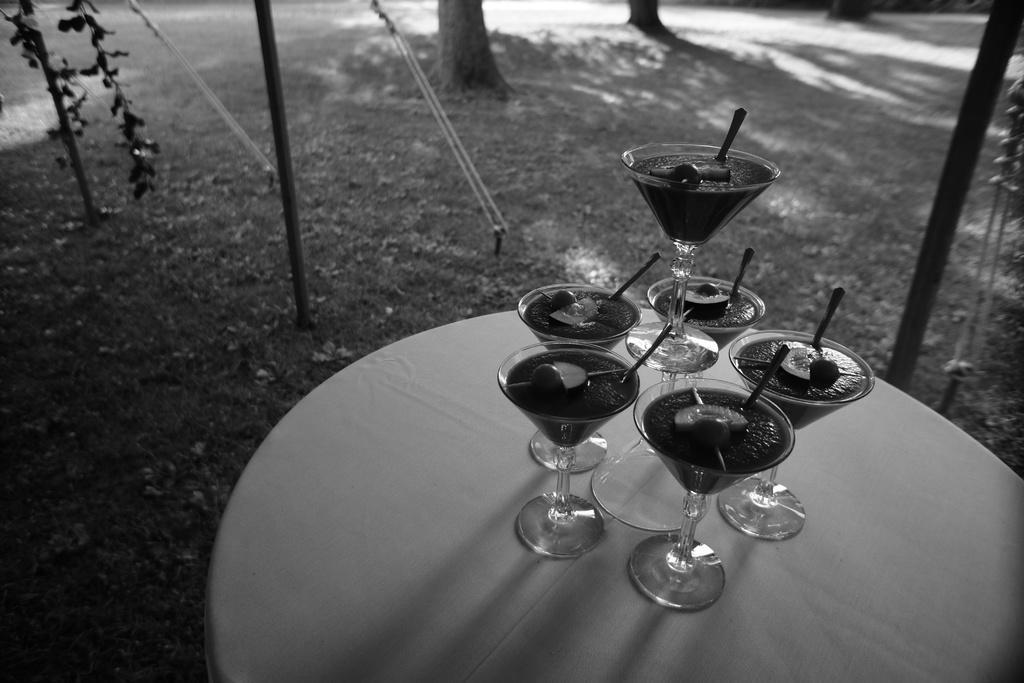In one or two sentences, can you explain what this image depicts? This is the picture of a table on which there are some glasses and around there are some plants and some things. 